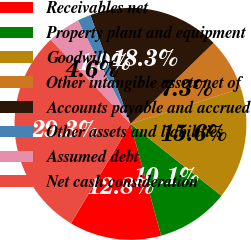Convert chart. <chart><loc_0><loc_0><loc_500><loc_500><pie_chart><fcel>Receivables net<fcel>Property plant and equipment<fcel>Goodwill<fcel>Other intangible assets net of<fcel>Accounts payable and accrued<fcel>Other assets and liabilities<fcel>Assumed debt<fcel>Net cash consideration<nl><fcel>12.84%<fcel>10.09%<fcel>15.59%<fcel>7.35%<fcel>18.34%<fcel>1.85%<fcel>4.6%<fcel>29.34%<nl></chart> 